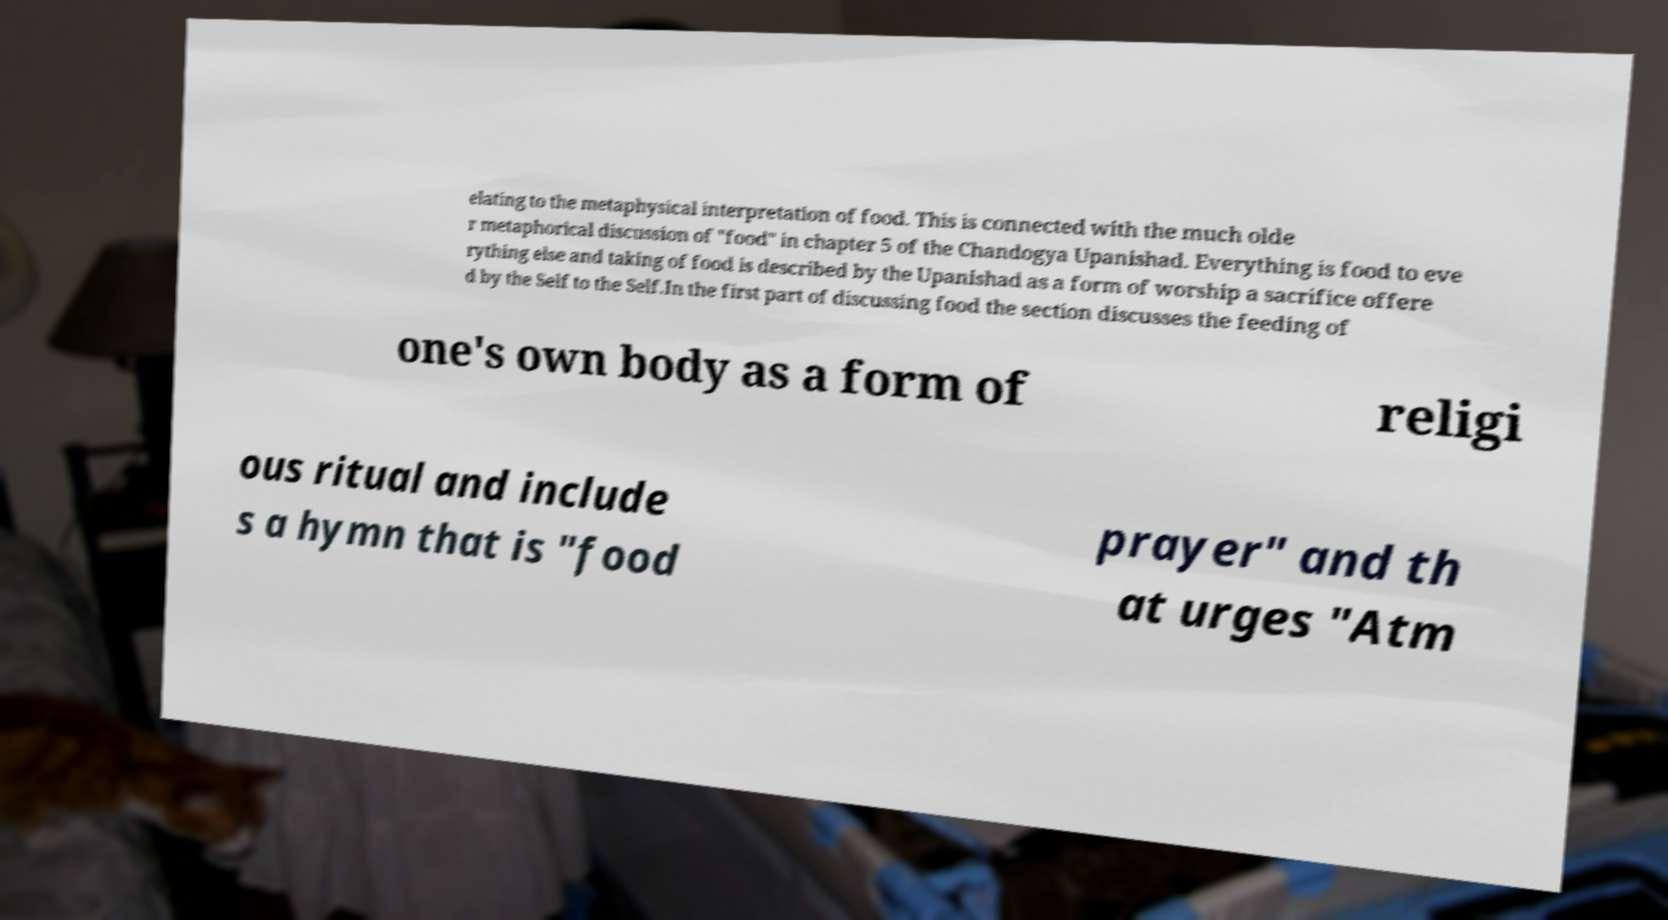I need the written content from this picture converted into text. Can you do that? elating to the metaphysical interpretation of food. This is connected with the much olde r metaphorical discussion of "food" in chapter 5 of the Chandogya Upanishad. Everything is food to eve rything else and taking of food is described by the Upanishad as a form of worship a sacrifice offere d by the Self to the Self.In the first part of discussing food the section discusses the feeding of one's own body as a form of religi ous ritual and include s a hymn that is "food prayer" and th at urges "Atm 